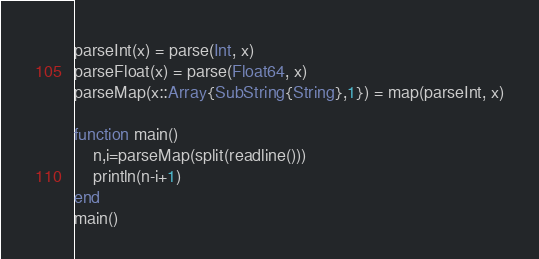Convert code to text. <code><loc_0><loc_0><loc_500><loc_500><_Julia_>parseInt(x) = parse(Int, x)
parseFloat(x) = parse(Float64, x)
parseMap(x::Array{SubString{String},1}) = map(parseInt, x)

function main()
    n,i=parseMap(split(readline()))
    println(n-i+1)
end
main()</code> 